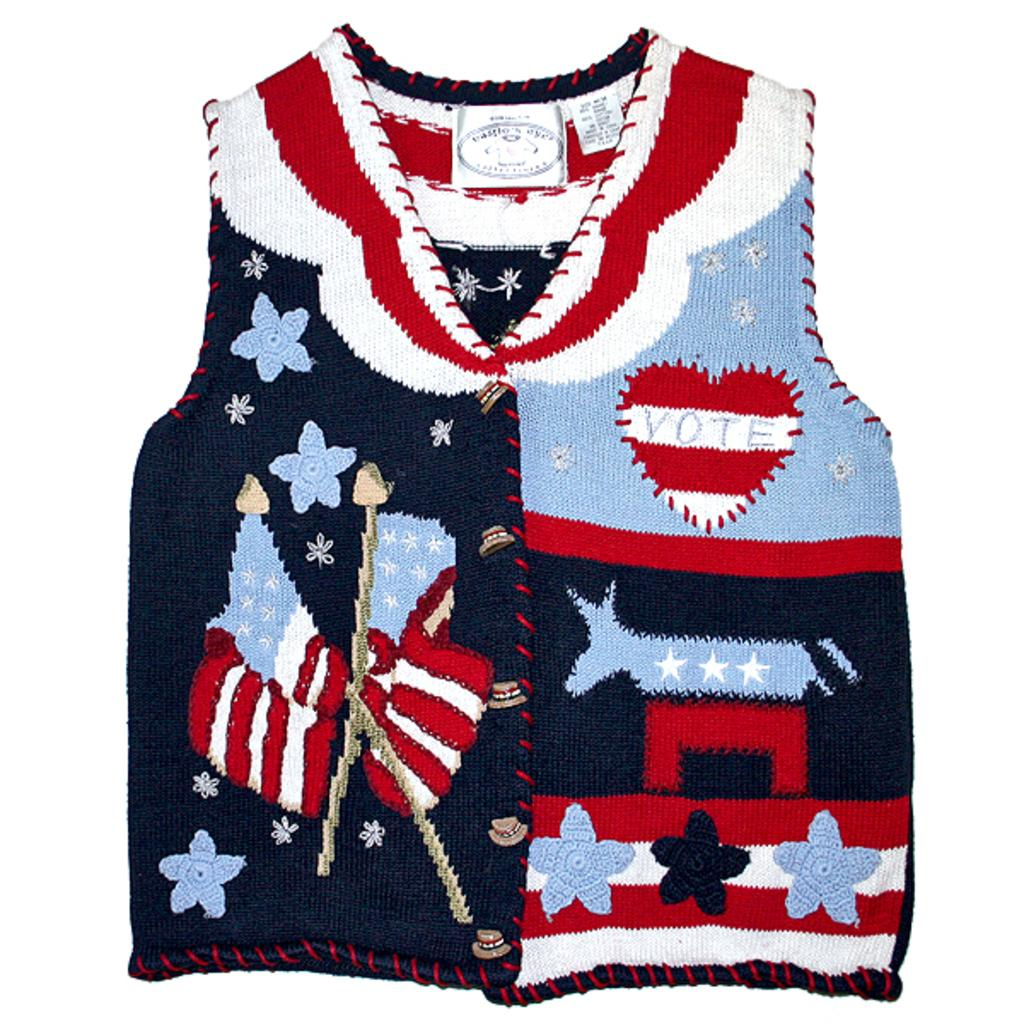<image>
Summarize the visual content of the image. Patriotic vest with a heart on the left breast with the word vote in light blue lettering. 